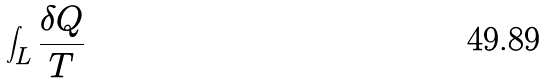<formula> <loc_0><loc_0><loc_500><loc_500>\int _ { L } \frac { \delta Q } { T }</formula> 